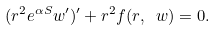Convert formula to latex. <formula><loc_0><loc_0><loc_500><loc_500>( r ^ { 2 } e ^ { \alpha S } w ^ { \prime } ) ^ { \prime } + r ^ { 2 } f ( r , \ w ) = 0 .</formula> 